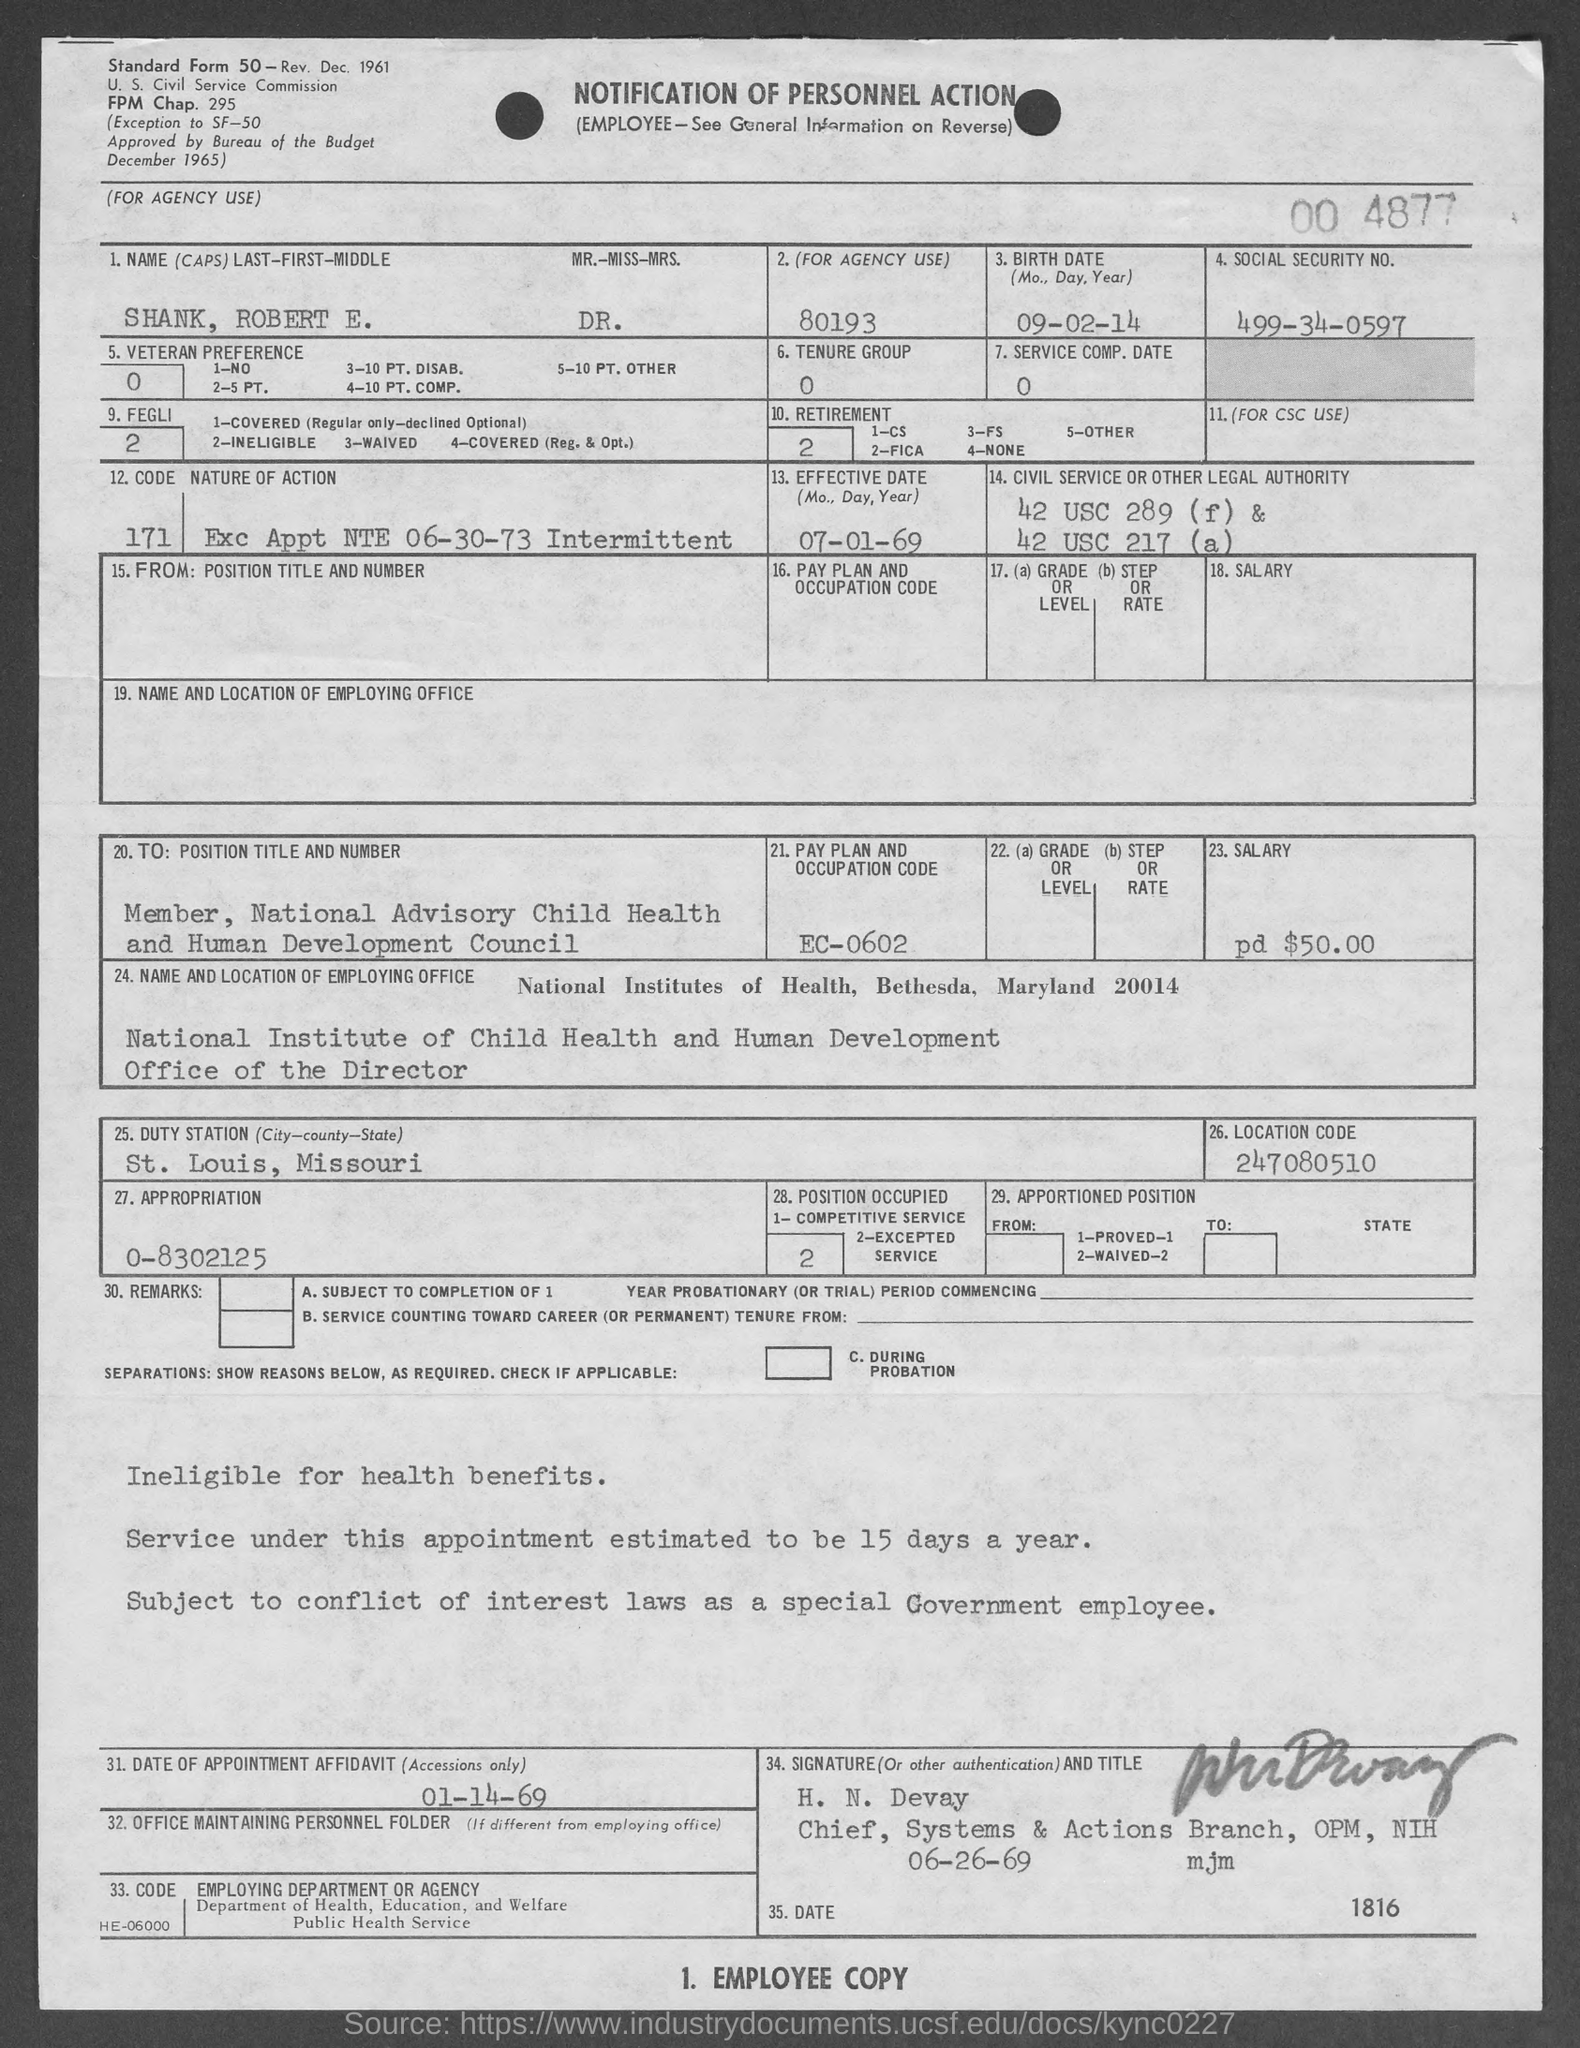What is the birth date of Dr. Robert E. Shank?
Provide a succinct answer. 09-02-14. What is the Social Security No. given in the form?
Provide a short and direct response. 499-34-0597. What is the Effective Date mentioned in the form?
Your answer should be compact. 07-01-69. What is the position title and number of Mr. Robert E. Shank?
Your answer should be very brief. Member, National Advisory Child Health and Human Development Council. What is the pay plan and occupation code mentioned in the form?
Provide a short and direct response. EC-0602. Which is the duty station of Mr. Robert E. Shank given in the form?
Offer a terse response. ST. LOUIS, MISSOURI. What is the location code given in the form?
Your answer should be compact. 247080510. What is the date of appointment affidavit given in the form?
Give a very brief answer. 01-14-69. 